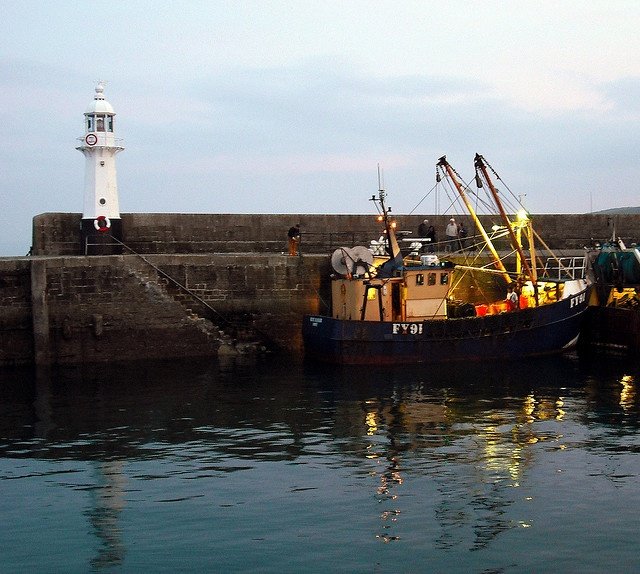Describe the objects in this image and their specific colors. I can see boat in lightblue, black, maroon, and brown tones, people in lightblue, black, maroon, and gray tones, people in lightblue, maroon, black, khaki, and gray tones, people in lightblue, black, maroon, gray, and darkgray tones, and people in lightblue, black, gray, maroon, and darkgray tones in this image. 